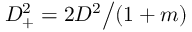<formula> <loc_0><loc_0><loc_500><loc_500>D _ { + } ^ { 2 } = 2 D ^ { 2 } \Big / ( 1 + m )</formula> 